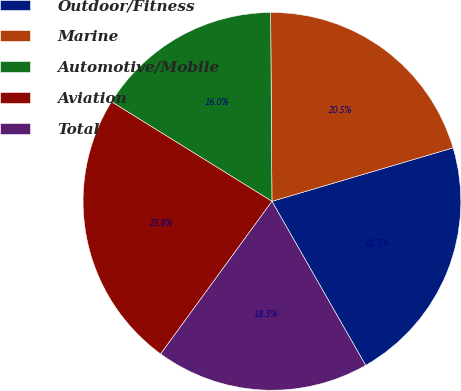Convert chart to OTSL. <chart><loc_0><loc_0><loc_500><loc_500><pie_chart><fcel>Outdoor/Fitness<fcel>Marine<fcel>Automotive/Mobile<fcel>Aviation<fcel>Total<nl><fcel>21.31%<fcel>20.54%<fcel>16.05%<fcel>23.81%<fcel>18.29%<nl></chart> 